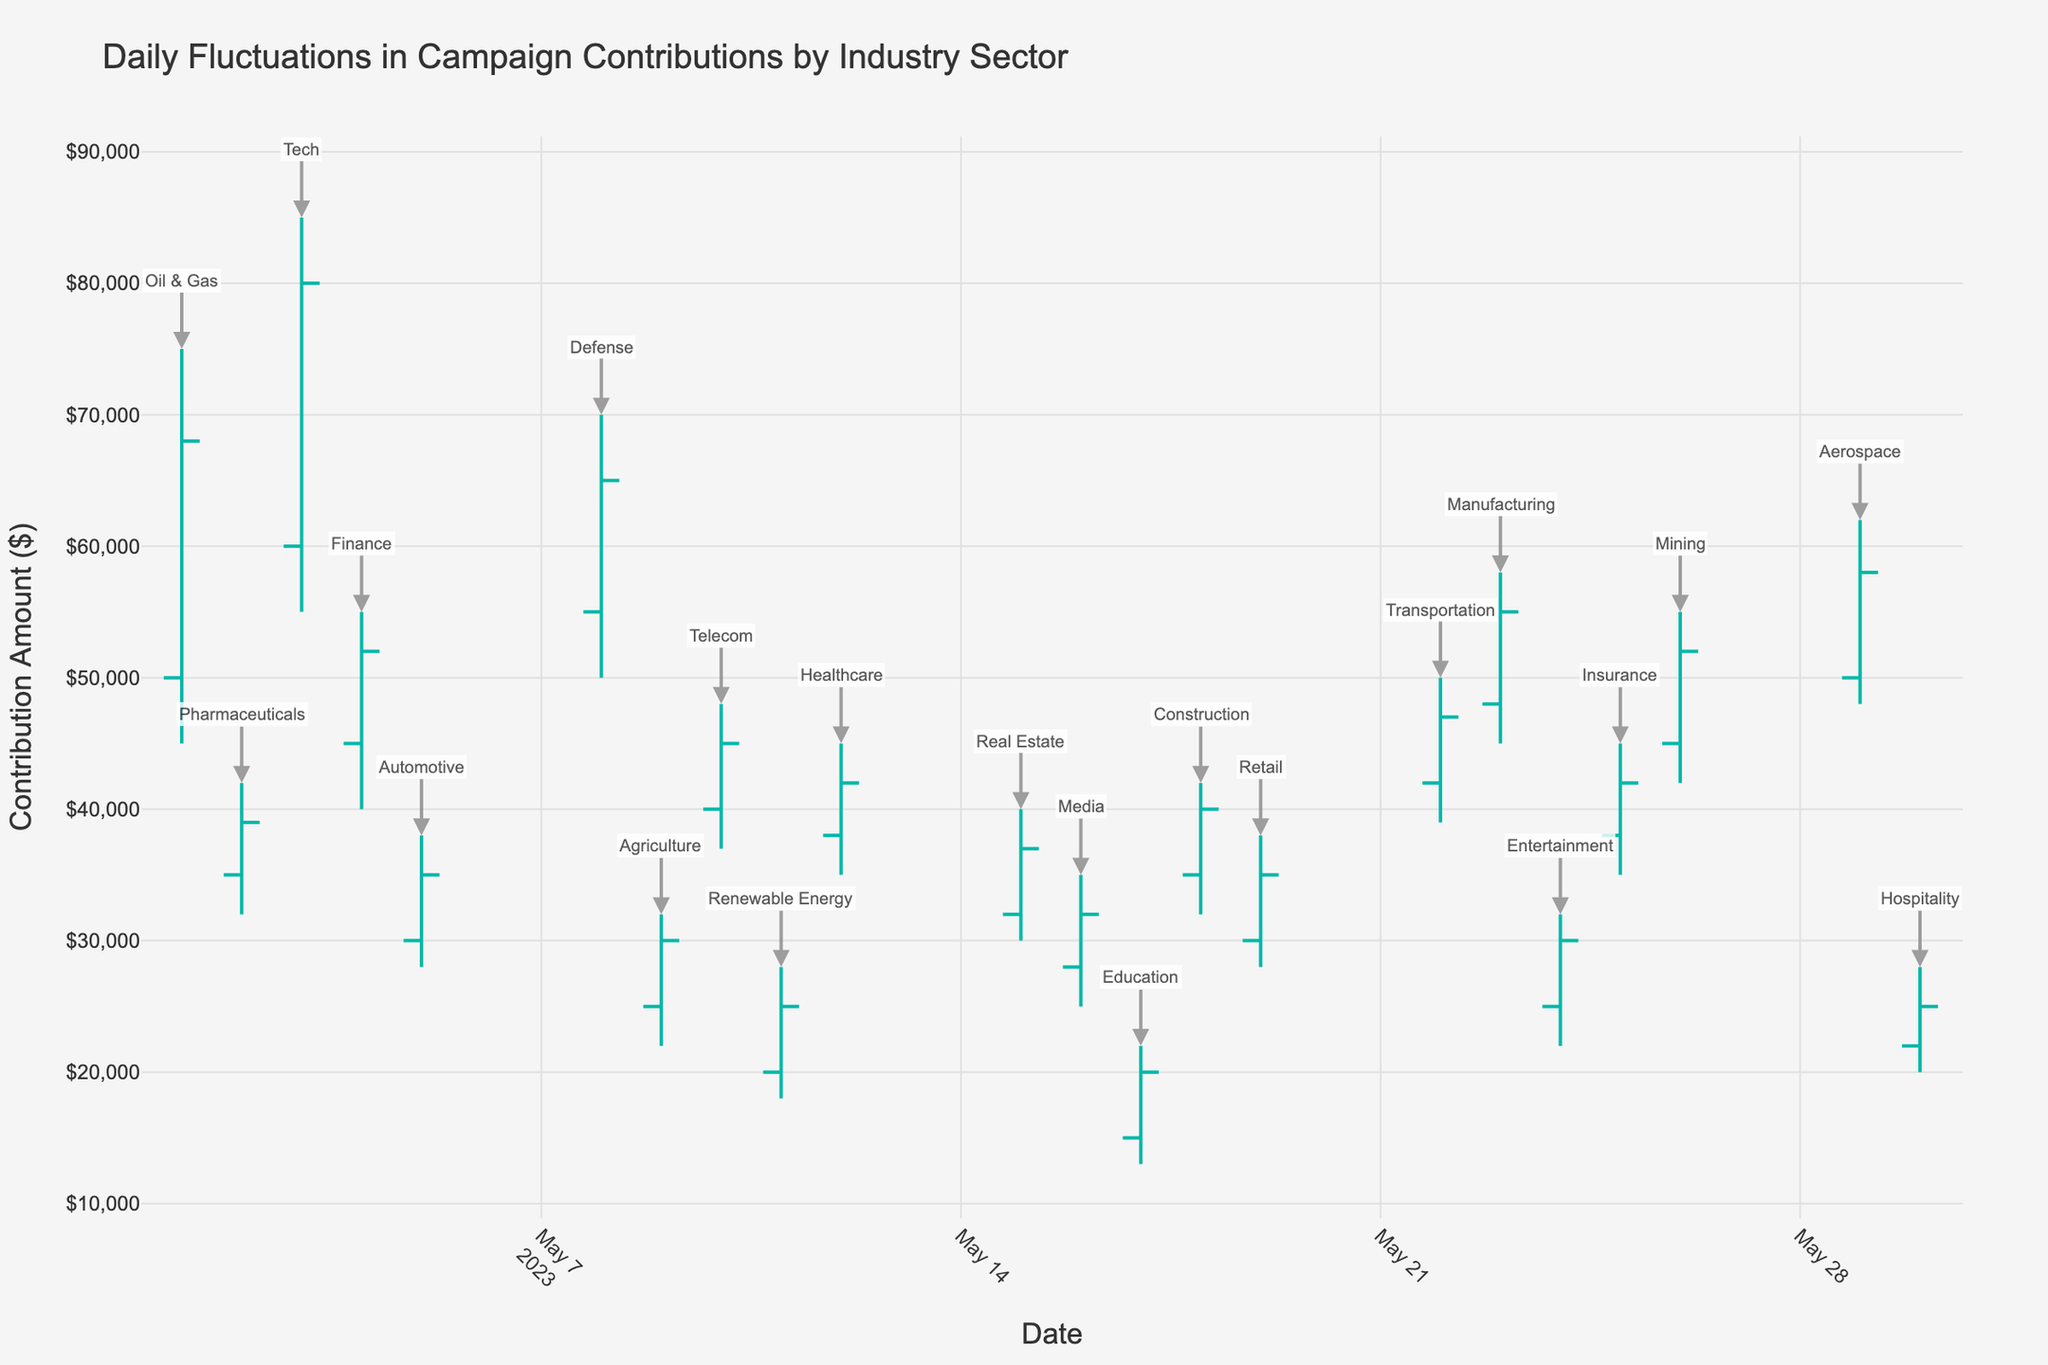What is the title of the chart? The chart's title is displayed at the top of the figure.
Answer: Daily Fluctuations in Campaign Contributions by Industry Sector How many sectors are represented in the chart? Each annotation near the high value represents a different sector. Count these annotations.
Answer: 22 Which sector has the highest daily close contribution amount? Look for the sector where the closing value is the highest among all entries. The closing value for Tech on 2023-05-03 is the highest at $80,000.
Answer: Tech What is the range of contributions for Oil & Gas on May 1, 2023? The range is defined by the difference between the high and low values on that date for this sector. High is $75,000 and Low is $45,000, so range is $75,000 - $45,000 = $30,000.
Answer: $30,000 How many sectors had their contributions increasing on their respective days? Identify bars where the close value is higher than the open value. Count such instances across the dataset.
Answer: 15 Which sector showed the lowest daily close contribution amount? Look for the sector with the lowest closing value. Education on 2023-05-17 has the lowest close at $20,000.
Answer: Education What is the overall highest contribution amount recorded, and which sector does it belong to? Find the highest "High" value in the chart and note the sector on that date. The highest is for Tech, recorded $85,000 on 2023-05-03.
Answer: $85,000, Tech Compare the opening contributions of Finance on May 4, 2023, and Defense on May 8, 2023. Which one is higher? Locate the opening values for Finance and Defense on their respective dates. Finance's opening is $45,000, and Defense's opening is $55,000. Defense has the higher opening contribution.
Answer: Defense What is the average closing contribution amount for sectors that had contributions peaking above $50,000? Identify sectors where the "High" value is above $50,000 and calculate the mean of their respective closing values. Sectors are Oil & Gas ($68,000), Tech ($80,000), Finance ($52,000), Defense ($65,000), Aerospace ($58,000), Mining ($52,000), and Manufacturing ($55,000). Average = ($68K + $80K + $52K + $65K + $58K + $52K + $55K) / 7 = $61,428.57.
Answer: $61,428.57 Which sector exhibited the most stable contributions, defined as the smallest difference between high and low values? Calculate the difference between high and low values for each sector and identify the smallest difference. Pharmaceuticals has the smallest difference of $10,000 (High $42,000 - Low $32,000).
Answer: Pharmaceuticals 